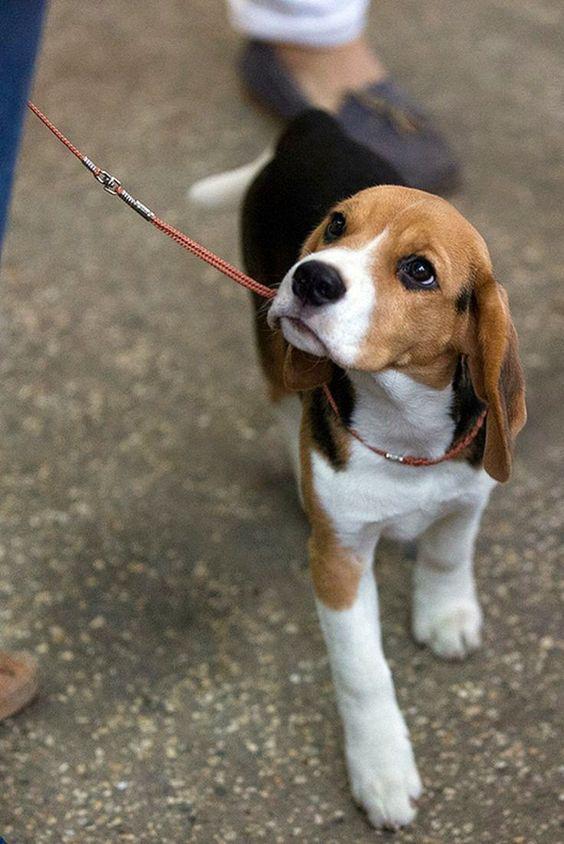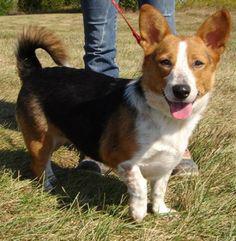The first image is the image on the left, the second image is the image on the right. Evaluate the accuracy of this statement regarding the images: "The dog in each image is on a leash.". Is it true? Answer yes or no. Yes. 